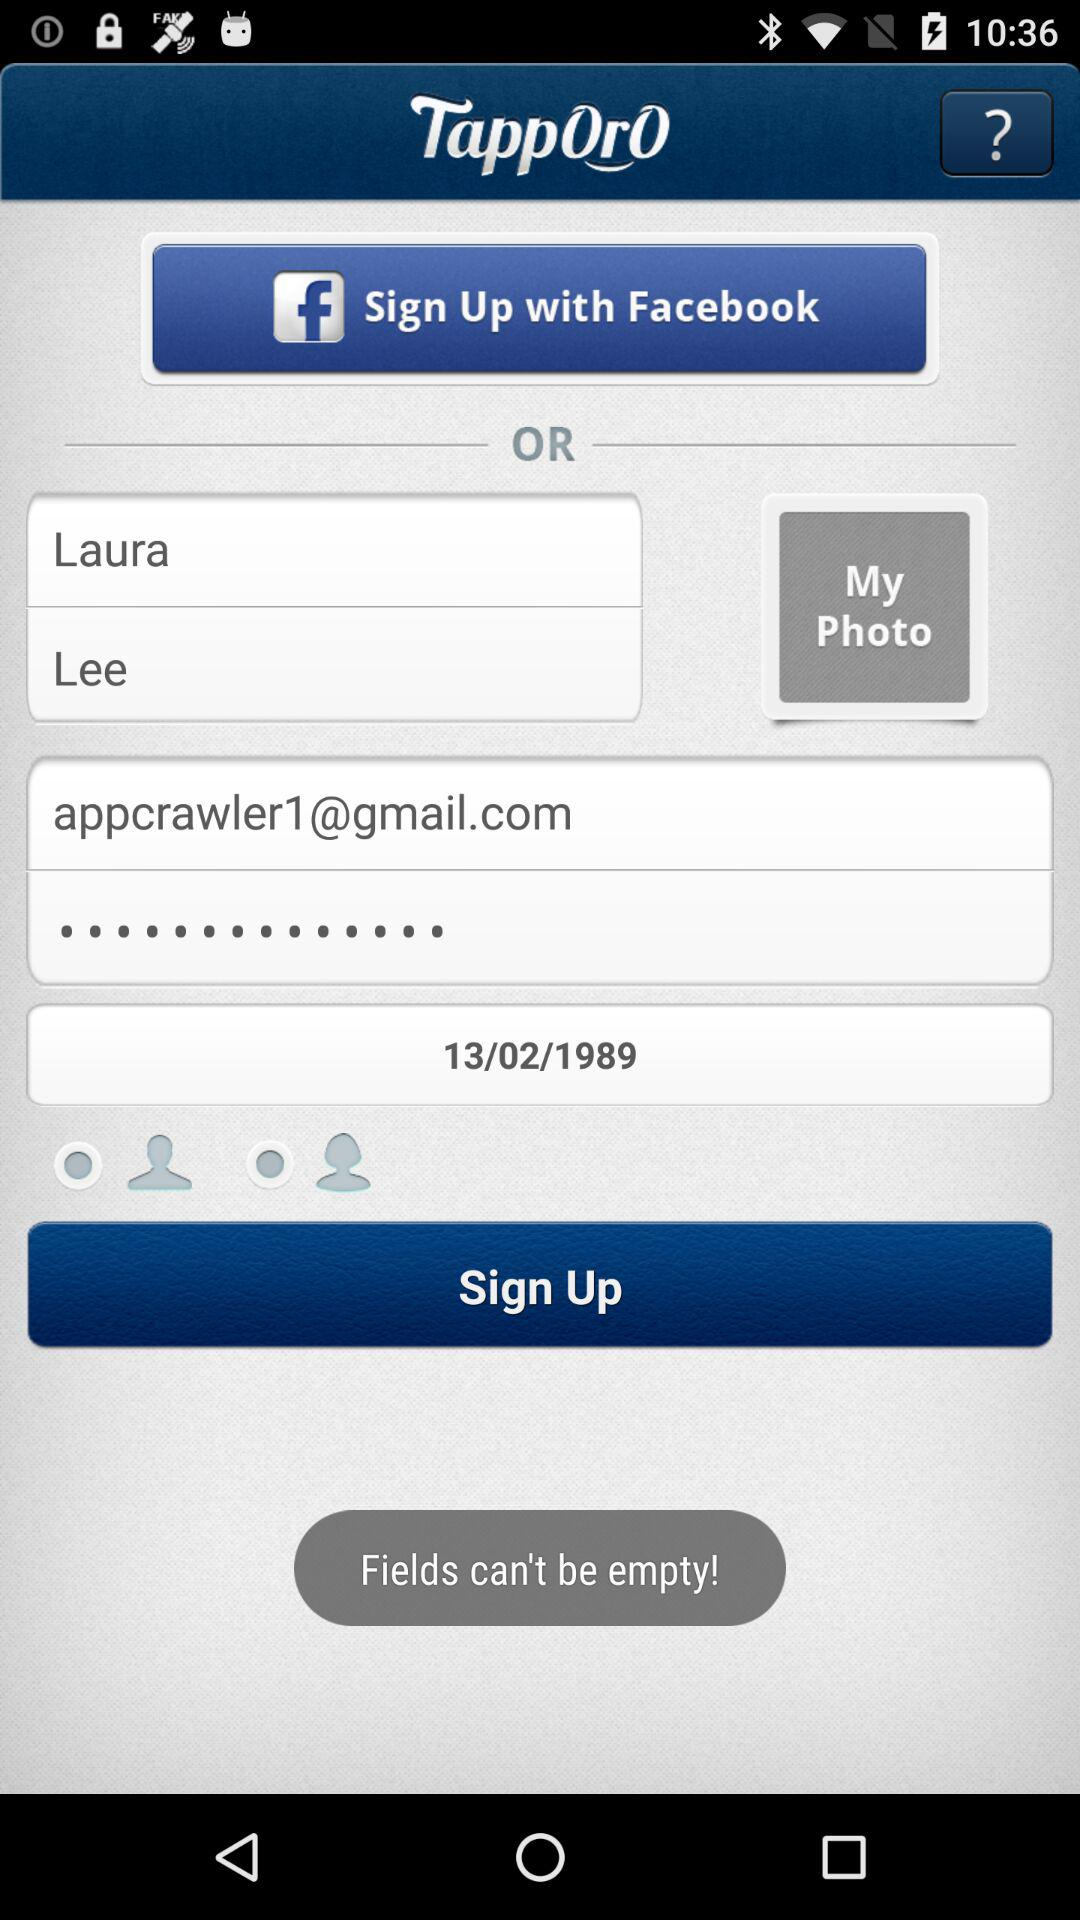What applications can be used to sign up to a profile? The application that can be used to sign up to a profile is "Facebook". 